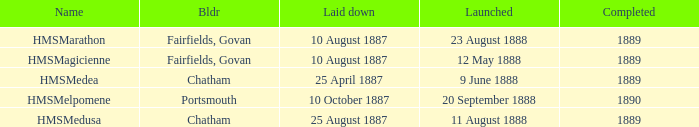Which builder completed before 1890 and launched on 9 june 1888? Chatham. 